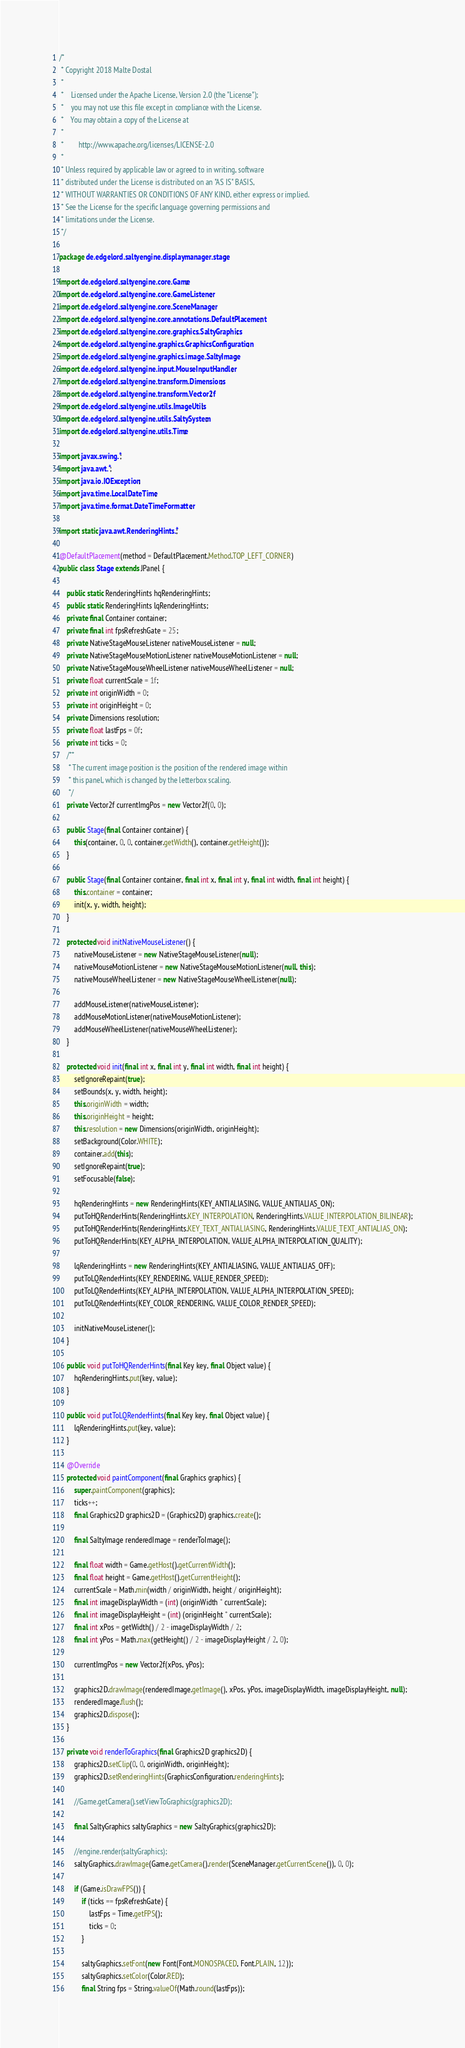<code> <loc_0><loc_0><loc_500><loc_500><_Java_>/*
 * Copyright 2018 Malte Dostal
 *
 *    Licensed under the Apache License, Version 2.0 (the "License");
 *    you may not use this file except in compliance with the License.
 *    You may obtain a copy of the License at
 *
 *        http://www.apache.org/licenses/LICENSE-2.0
 *
 * Unless required by applicable law or agreed to in writing, software
 * distributed under the License is distributed on an "AS IS" BASIS,
 * WITHOUT WARRANTIES OR CONDITIONS OF ANY KIND, either express or implied.
 * See the License for the specific language governing permissions and
 * limitations under the License.
 */

package de.edgelord.saltyengine.displaymanager.stage;

import de.edgelord.saltyengine.core.Game;
import de.edgelord.saltyengine.core.GameListener;
import de.edgelord.saltyengine.core.SceneManager;
import de.edgelord.saltyengine.core.annotations.DefaultPlacement;
import de.edgelord.saltyengine.core.graphics.SaltyGraphics;
import de.edgelord.saltyengine.graphics.GraphicsConfiguration;
import de.edgelord.saltyengine.graphics.image.SaltyImage;
import de.edgelord.saltyengine.input.MouseInputHandler;
import de.edgelord.saltyengine.transform.Dimensions;
import de.edgelord.saltyengine.transform.Vector2f;
import de.edgelord.saltyengine.utils.ImageUtils;
import de.edgelord.saltyengine.utils.SaltySystem;
import de.edgelord.saltyengine.utils.Time;

import javax.swing.*;
import java.awt.*;
import java.io.IOException;
import java.time.LocalDateTime;
import java.time.format.DateTimeFormatter;

import static java.awt.RenderingHints.*;

@DefaultPlacement(method = DefaultPlacement.Method.TOP_LEFT_CORNER)
public class Stage extends JPanel {

    public static RenderingHints hqRenderingHints;
    public static RenderingHints lqRenderingHints;
    private final Container container;
    private final int fpsRefreshGate = 25;
    private NativeStageMouseListener nativeMouseListener = null;
    private NativeStageMouseMotionListener nativeMouseMotionListener = null;
    private NativeStageMouseWheelListener nativeMouseWheelListener = null;
    private float currentScale = 1f;
    private int originWidth = 0;
    private int originHeight = 0;
    private Dimensions resolution;
    private float lastFps = 0f;
    private int ticks = 0;
    /**
     * The current image position is the position of the rendered image within
     * this panel, which is changed by the letterbox scaling.
     */
    private Vector2f currentImgPos = new Vector2f(0, 0);

    public Stage(final Container container) {
        this(container, 0, 0, container.getWidth(), container.getHeight());
    }

    public Stage(final Container container, final int x, final int y, final int width, final int height) {
        this.container = container;
        init(x, y, width, height);
    }

    protected void initNativeMouseListener() {
        nativeMouseListener = new NativeStageMouseListener(null);
        nativeMouseMotionListener = new NativeStageMouseMotionListener(null, this);
        nativeMouseWheelListener = new NativeStageMouseWheelListener(null);

        addMouseListener(nativeMouseListener);
        addMouseMotionListener(nativeMouseMotionListener);
        addMouseWheelListener(nativeMouseWheelListener);
    }

    protected void init(final int x, final int y, final int width, final int height) {
        setIgnoreRepaint(true);
        setBounds(x, y, width, height);
        this.originWidth = width;
        this.originHeight = height;
        this.resolution = new Dimensions(originWidth, originHeight);
        setBackground(Color.WHITE);
        container.add(this);
        setIgnoreRepaint(true);
        setFocusable(false);

        hqRenderingHints = new RenderingHints(KEY_ANTIALIASING, VALUE_ANTIALIAS_ON);
        putToHQRenderHints(RenderingHints.KEY_INTERPOLATION, RenderingHints.VALUE_INTERPOLATION_BILINEAR);
        putToHQRenderHints(RenderingHints.KEY_TEXT_ANTIALIASING, RenderingHints.VALUE_TEXT_ANTIALIAS_ON);
        putToHQRenderHints(KEY_ALPHA_INTERPOLATION, VALUE_ALPHA_INTERPOLATION_QUALITY);

        lqRenderingHints = new RenderingHints(KEY_ANTIALIASING, VALUE_ANTIALIAS_OFF);
        putToLQRenderHints(KEY_RENDERING, VALUE_RENDER_SPEED);
        putToLQRenderHints(KEY_ALPHA_INTERPOLATION, VALUE_ALPHA_INTERPOLATION_SPEED);
        putToLQRenderHints(KEY_COLOR_RENDERING, VALUE_COLOR_RENDER_SPEED);

        initNativeMouseListener();
    }

    public void putToHQRenderHints(final Key key, final Object value) {
        hqRenderingHints.put(key, value);
    }

    public void putToLQRenderHints(final Key key, final Object value) {
        lqRenderingHints.put(key, value);
    }

    @Override
    protected void paintComponent(final Graphics graphics) {
        super.paintComponent(graphics);
        ticks++;
        final Graphics2D graphics2D = (Graphics2D) graphics.create();

        final SaltyImage renderedImage = renderToImage();

        final float width = Game.getHost().getCurrentWidth();
        final float height = Game.getHost().getCurrentHeight();
        currentScale = Math.min(width / originWidth, height / originHeight);
        final int imageDisplayWidth = (int) (originWidth * currentScale);
        final int imageDisplayHeight = (int) (originHeight * currentScale);
        final int xPos = getWidth() / 2 - imageDisplayWidth / 2;
        final int yPos = Math.max(getHeight() / 2 - imageDisplayHeight / 2, 0);

        currentImgPos = new Vector2f(xPos, yPos);

        graphics2D.drawImage(renderedImage.getImage(), xPos, yPos, imageDisplayWidth, imageDisplayHeight, null);
        renderedImage.flush();
        graphics2D.dispose();
    }

    private void renderToGraphics(final Graphics2D graphics2D) {
        graphics2D.setClip(0, 0, originWidth, originHeight);
        graphics2D.setRenderingHints(GraphicsConfiguration.renderingHints);

        //Game.getCamera().setViewToGraphics(graphics2D);

        final SaltyGraphics saltyGraphics = new SaltyGraphics(graphics2D);

        //engine.render(saltyGraphics);
        saltyGraphics.drawImage(Game.getCamera().render(SceneManager.getCurrentScene()), 0, 0);

        if (Game.isDrawFPS()) {
            if (ticks == fpsRefreshGate) {
                lastFps = Time.getFPS();
                ticks = 0;
            }

            saltyGraphics.setFont(new Font(Font.MONOSPACED, Font.PLAIN, 12));
            saltyGraphics.setColor(Color.RED);
            final String fps = String.valueOf(Math.round(lastFps));</code> 